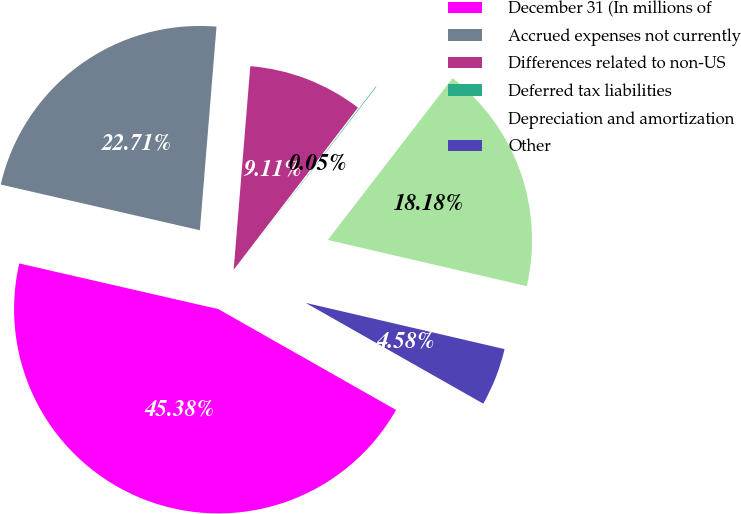Convert chart to OTSL. <chart><loc_0><loc_0><loc_500><loc_500><pie_chart><fcel>December 31 (In millions of<fcel>Accrued expenses not currently<fcel>Differences related to non-US<fcel>Deferred tax liabilities<fcel>Depreciation and amortization<fcel>Other<nl><fcel>45.38%<fcel>22.71%<fcel>9.11%<fcel>0.05%<fcel>18.18%<fcel>4.58%<nl></chart> 